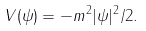<formula> <loc_0><loc_0><loc_500><loc_500>V ( \psi ) = - m ^ { 2 } | \psi | ^ { 2 } / 2 .</formula> 